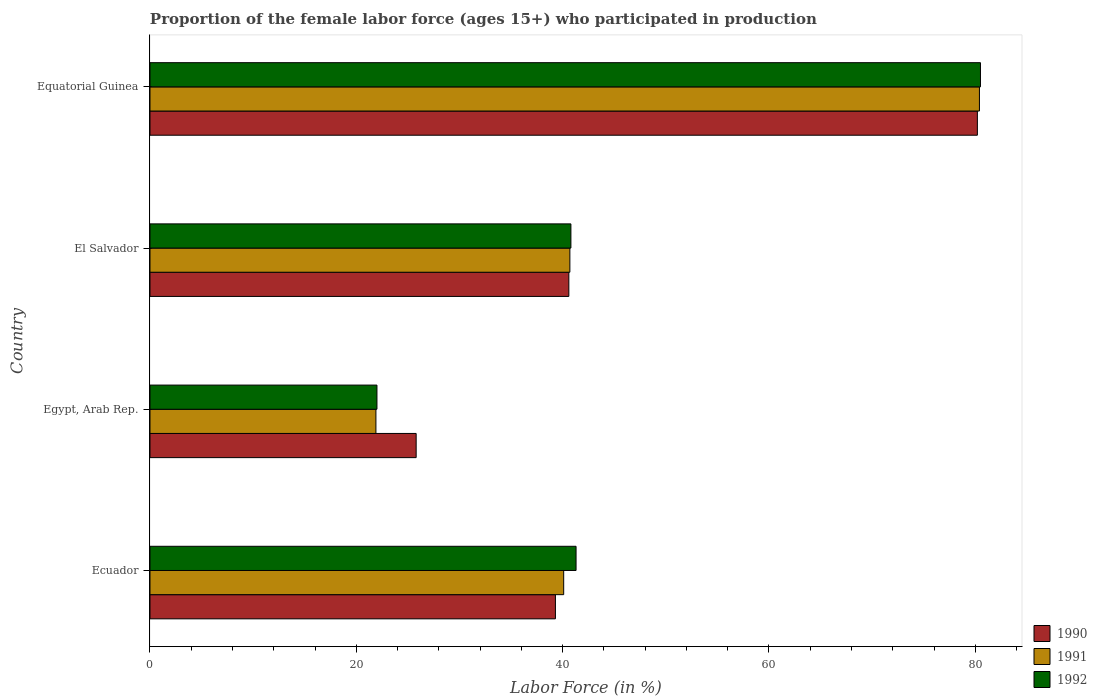Are the number of bars per tick equal to the number of legend labels?
Your answer should be very brief. Yes. How many bars are there on the 3rd tick from the top?
Your answer should be very brief. 3. What is the label of the 3rd group of bars from the top?
Keep it short and to the point. Egypt, Arab Rep. In how many cases, is the number of bars for a given country not equal to the number of legend labels?
Offer a very short reply. 0. What is the proportion of the female labor force who participated in production in 1991 in Egypt, Arab Rep.?
Offer a very short reply. 21.9. Across all countries, what is the maximum proportion of the female labor force who participated in production in 1990?
Your answer should be very brief. 80.2. In which country was the proportion of the female labor force who participated in production in 1991 maximum?
Keep it short and to the point. Equatorial Guinea. In which country was the proportion of the female labor force who participated in production in 1991 minimum?
Offer a very short reply. Egypt, Arab Rep. What is the total proportion of the female labor force who participated in production in 1992 in the graph?
Your answer should be very brief. 184.6. What is the difference between the proportion of the female labor force who participated in production in 1990 in Ecuador and that in El Salvador?
Offer a very short reply. -1.3. What is the difference between the proportion of the female labor force who participated in production in 1992 in El Salvador and the proportion of the female labor force who participated in production in 1990 in Ecuador?
Give a very brief answer. 1.5. What is the average proportion of the female labor force who participated in production in 1991 per country?
Provide a succinct answer. 45.78. What is the difference between the proportion of the female labor force who participated in production in 1990 and proportion of the female labor force who participated in production in 1991 in Ecuador?
Provide a succinct answer. -0.8. In how many countries, is the proportion of the female labor force who participated in production in 1992 greater than 68 %?
Keep it short and to the point. 1. What is the ratio of the proportion of the female labor force who participated in production in 1990 in Ecuador to that in Equatorial Guinea?
Provide a succinct answer. 0.49. Is the proportion of the female labor force who participated in production in 1991 in El Salvador less than that in Equatorial Guinea?
Offer a very short reply. Yes. Is the difference between the proportion of the female labor force who participated in production in 1990 in Egypt, Arab Rep. and El Salvador greater than the difference between the proportion of the female labor force who participated in production in 1991 in Egypt, Arab Rep. and El Salvador?
Your answer should be compact. Yes. What is the difference between the highest and the second highest proportion of the female labor force who participated in production in 1991?
Your response must be concise. 39.7. What is the difference between the highest and the lowest proportion of the female labor force who participated in production in 1991?
Offer a terse response. 58.5. In how many countries, is the proportion of the female labor force who participated in production in 1990 greater than the average proportion of the female labor force who participated in production in 1990 taken over all countries?
Offer a terse response. 1. Is the sum of the proportion of the female labor force who participated in production in 1991 in Ecuador and Equatorial Guinea greater than the maximum proportion of the female labor force who participated in production in 1990 across all countries?
Provide a succinct answer. Yes. What is the difference between two consecutive major ticks on the X-axis?
Your answer should be compact. 20. Are the values on the major ticks of X-axis written in scientific E-notation?
Provide a succinct answer. No. What is the title of the graph?
Provide a short and direct response. Proportion of the female labor force (ages 15+) who participated in production. Does "2005" appear as one of the legend labels in the graph?
Make the answer very short. No. What is the Labor Force (in %) in 1990 in Ecuador?
Make the answer very short. 39.3. What is the Labor Force (in %) of 1991 in Ecuador?
Ensure brevity in your answer.  40.1. What is the Labor Force (in %) in 1992 in Ecuador?
Provide a succinct answer. 41.3. What is the Labor Force (in %) in 1990 in Egypt, Arab Rep.?
Your answer should be very brief. 25.8. What is the Labor Force (in %) in 1991 in Egypt, Arab Rep.?
Provide a short and direct response. 21.9. What is the Labor Force (in %) in 1990 in El Salvador?
Provide a short and direct response. 40.6. What is the Labor Force (in %) of 1991 in El Salvador?
Offer a terse response. 40.7. What is the Labor Force (in %) of 1992 in El Salvador?
Your answer should be compact. 40.8. What is the Labor Force (in %) in 1990 in Equatorial Guinea?
Provide a short and direct response. 80.2. What is the Labor Force (in %) of 1991 in Equatorial Guinea?
Offer a terse response. 80.4. What is the Labor Force (in %) of 1992 in Equatorial Guinea?
Your response must be concise. 80.5. Across all countries, what is the maximum Labor Force (in %) of 1990?
Your answer should be very brief. 80.2. Across all countries, what is the maximum Labor Force (in %) of 1991?
Give a very brief answer. 80.4. Across all countries, what is the maximum Labor Force (in %) in 1992?
Provide a succinct answer. 80.5. Across all countries, what is the minimum Labor Force (in %) of 1990?
Ensure brevity in your answer.  25.8. Across all countries, what is the minimum Labor Force (in %) of 1991?
Keep it short and to the point. 21.9. Across all countries, what is the minimum Labor Force (in %) in 1992?
Offer a terse response. 22. What is the total Labor Force (in %) of 1990 in the graph?
Provide a succinct answer. 185.9. What is the total Labor Force (in %) in 1991 in the graph?
Keep it short and to the point. 183.1. What is the total Labor Force (in %) in 1992 in the graph?
Your answer should be compact. 184.6. What is the difference between the Labor Force (in %) of 1990 in Ecuador and that in Egypt, Arab Rep.?
Offer a very short reply. 13.5. What is the difference between the Labor Force (in %) in 1991 in Ecuador and that in Egypt, Arab Rep.?
Offer a very short reply. 18.2. What is the difference between the Labor Force (in %) of 1992 in Ecuador and that in Egypt, Arab Rep.?
Provide a succinct answer. 19.3. What is the difference between the Labor Force (in %) of 1990 in Ecuador and that in El Salvador?
Give a very brief answer. -1.3. What is the difference between the Labor Force (in %) of 1991 in Ecuador and that in El Salvador?
Provide a short and direct response. -0.6. What is the difference between the Labor Force (in %) in 1992 in Ecuador and that in El Salvador?
Give a very brief answer. 0.5. What is the difference between the Labor Force (in %) in 1990 in Ecuador and that in Equatorial Guinea?
Make the answer very short. -40.9. What is the difference between the Labor Force (in %) of 1991 in Ecuador and that in Equatorial Guinea?
Your response must be concise. -40.3. What is the difference between the Labor Force (in %) of 1992 in Ecuador and that in Equatorial Guinea?
Keep it short and to the point. -39.2. What is the difference between the Labor Force (in %) of 1990 in Egypt, Arab Rep. and that in El Salvador?
Provide a short and direct response. -14.8. What is the difference between the Labor Force (in %) in 1991 in Egypt, Arab Rep. and that in El Salvador?
Provide a succinct answer. -18.8. What is the difference between the Labor Force (in %) of 1992 in Egypt, Arab Rep. and that in El Salvador?
Provide a succinct answer. -18.8. What is the difference between the Labor Force (in %) in 1990 in Egypt, Arab Rep. and that in Equatorial Guinea?
Keep it short and to the point. -54.4. What is the difference between the Labor Force (in %) of 1991 in Egypt, Arab Rep. and that in Equatorial Guinea?
Keep it short and to the point. -58.5. What is the difference between the Labor Force (in %) of 1992 in Egypt, Arab Rep. and that in Equatorial Guinea?
Provide a short and direct response. -58.5. What is the difference between the Labor Force (in %) of 1990 in El Salvador and that in Equatorial Guinea?
Your response must be concise. -39.6. What is the difference between the Labor Force (in %) of 1991 in El Salvador and that in Equatorial Guinea?
Keep it short and to the point. -39.7. What is the difference between the Labor Force (in %) in 1992 in El Salvador and that in Equatorial Guinea?
Provide a short and direct response. -39.7. What is the difference between the Labor Force (in %) of 1991 in Ecuador and the Labor Force (in %) of 1992 in Egypt, Arab Rep.?
Provide a short and direct response. 18.1. What is the difference between the Labor Force (in %) of 1990 in Ecuador and the Labor Force (in %) of 1991 in El Salvador?
Offer a terse response. -1.4. What is the difference between the Labor Force (in %) in 1990 in Ecuador and the Labor Force (in %) in 1992 in El Salvador?
Your response must be concise. -1.5. What is the difference between the Labor Force (in %) in 1991 in Ecuador and the Labor Force (in %) in 1992 in El Salvador?
Provide a short and direct response. -0.7. What is the difference between the Labor Force (in %) in 1990 in Ecuador and the Labor Force (in %) in 1991 in Equatorial Guinea?
Your answer should be very brief. -41.1. What is the difference between the Labor Force (in %) of 1990 in Ecuador and the Labor Force (in %) of 1992 in Equatorial Guinea?
Your answer should be very brief. -41.2. What is the difference between the Labor Force (in %) in 1991 in Ecuador and the Labor Force (in %) in 1992 in Equatorial Guinea?
Offer a very short reply. -40.4. What is the difference between the Labor Force (in %) in 1990 in Egypt, Arab Rep. and the Labor Force (in %) in 1991 in El Salvador?
Make the answer very short. -14.9. What is the difference between the Labor Force (in %) of 1991 in Egypt, Arab Rep. and the Labor Force (in %) of 1992 in El Salvador?
Provide a short and direct response. -18.9. What is the difference between the Labor Force (in %) of 1990 in Egypt, Arab Rep. and the Labor Force (in %) of 1991 in Equatorial Guinea?
Make the answer very short. -54.6. What is the difference between the Labor Force (in %) of 1990 in Egypt, Arab Rep. and the Labor Force (in %) of 1992 in Equatorial Guinea?
Keep it short and to the point. -54.7. What is the difference between the Labor Force (in %) of 1991 in Egypt, Arab Rep. and the Labor Force (in %) of 1992 in Equatorial Guinea?
Your answer should be compact. -58.6. What is the difference between the Labor Force (in %) in 1990 in El Salvador and the Labor Force (in %) in 1991 in Equatorial Guinea?
Ensure brevity in your answer.  -39.8. What is the difference between the Labor Force (in %) of 1990 in El Salvador and the Labor Force (in %) of 1992 in Equatorial Guinea?
Make the answer very short. -39.9. What is the difference between the Labor Force (in %) of 1991 in El Salvador and the Labor Force (in %) of 1992 in Equatorial Guinea?
Provide a succinct answer. -39.8. What is the average Labor Force (in %) of 1990 per country?
Keep it short and to the point. 46.48. What is the average Labor Force (in %) in 1991 per country?
Ensure brevity in your answer.  45.77. What is the average Labor Force (in %) in 1992 per country?
Keep it short and to the point. 46.15. What is the difference between the Labor Force (in %) of 1990 and Labor Force (in %) of 1991 in Ecuador?
Your answer should be very brief. -0.8. What is the difference between the Labor Force (in %) of 1991 and Labor Force (in %) of 1992 in Ecuador?
Ensure brevity in your answer.  -1.2. What is the difference between the Labor Force (in %) of 1990 and Labor Force (in %) of 1991 in Egypt, Arab Rep.?
Keep it short and to the point. 3.9. What is the difference between the Labor Force (in %) of 1990 and Labor Force (in %) of 1991 in El Salvador?
Make the answer very short. -0.1. What is the ratio of the Labor Force (in %) in 1990 in Ecuador to that in Egypt, Arab Rep.?
Your answer should be very brief. 1.52. What is the ratio of the Labor Force (in %) in 1991 in Ecuador to that in Egypt, Arab Rep.?
Your answer should be compact. 1.83. What is the ratio of the Labor Force (in %) of 1992 in Ecuador to that in Egypt, Arab Rep.?
Your answer should be compact. 1.88. What is the ratio of the Labor Force (in %) of 1992 in Ecuador to that in El Salvador?
Make the answer very short. 1.01. What is the ratio of the Labor Force (in %) in 1990 in Ecuador to that in Equatorial Guinea?
Your answer should be very brief. 0.49. What is the ratio of the Labor Force (in %) of 1991 in Ecuador to that in Equatorial Guinea?
Provide a short and direct response. 0.5. What is the ratio of the Labor Force (in %) of 1992 in Ecuador to that in Equatorial Guinea?
Your answer should be very brief. 0.51. What is the ratio of the Labor Force (in %) in 1990 in Egypt, Arab Rep. to that in El Salvador?
Your answer should be very brief. 0.64. What is the ratio of the Labor Force (in %) in 1991 in Egypt, Arab Rep. to that in El Salvador?
Your response must be concise. 0.54. What is the ratio of the Labor Force (in %) of 1992 in Egypt, Arab Rep. to that in El Salvador?
Your answer should be very brief. 0.54. What is the ratio of the Labor Force (in %) in 1990 in Egypt, Arab Rep. to that in Equatorial Guinea?
Your answer should be very brief. 0.32. What is the ratio of the Labor Force (in %) in 1991 in Egypt, Arab Rep. to that in Equatorial Guinea?
Your answer should be compact. 0.27. What is the ratio of the Labor Force (in %) in 1992 in Egypt, Arab Rep. to that in Equatorial Guinea?
Ensure brevity in your answer.  0.27. What is the ratio of the Labor Force (in %) in 1990 in El Salvador to that in Equatorial Guinea?
Ensure brevity in your answer.  0.51. What is the ratio of the Labor Force (in %) of 1991 in El Salvador to that in Equatorial Guinea?
Offer a terse response. 0.51. What is the ratio of the Labor Force (in %) in 1992 in El Salvador to that in Equatorial Guinea?
Your answer should be compact. 0.51. What is the difference between the highest and the second highest Labor Force (in %) of 1990?
Your answer should be compact. 39.6. What is the difference between the highest and the second highest Labor Force (in %) of 1991?
Give a very brief answer. 39.7. What is the difference between the highest and the second highest Labor Force (in %) of 1992?
Offer a terse response. 39.2. What is the difference between the highest and the lowest Labor Force (in %) in 1990?
Your response must be concise. 54.4. What is the difference between the highest and the lowest Labor Force (in %) in 1991?
Your answer should be very brief. 58.5. What is the difference between the highest and the lowest Labor Force (in %) of 1992?
Provide a short and direct response. 58.5. 